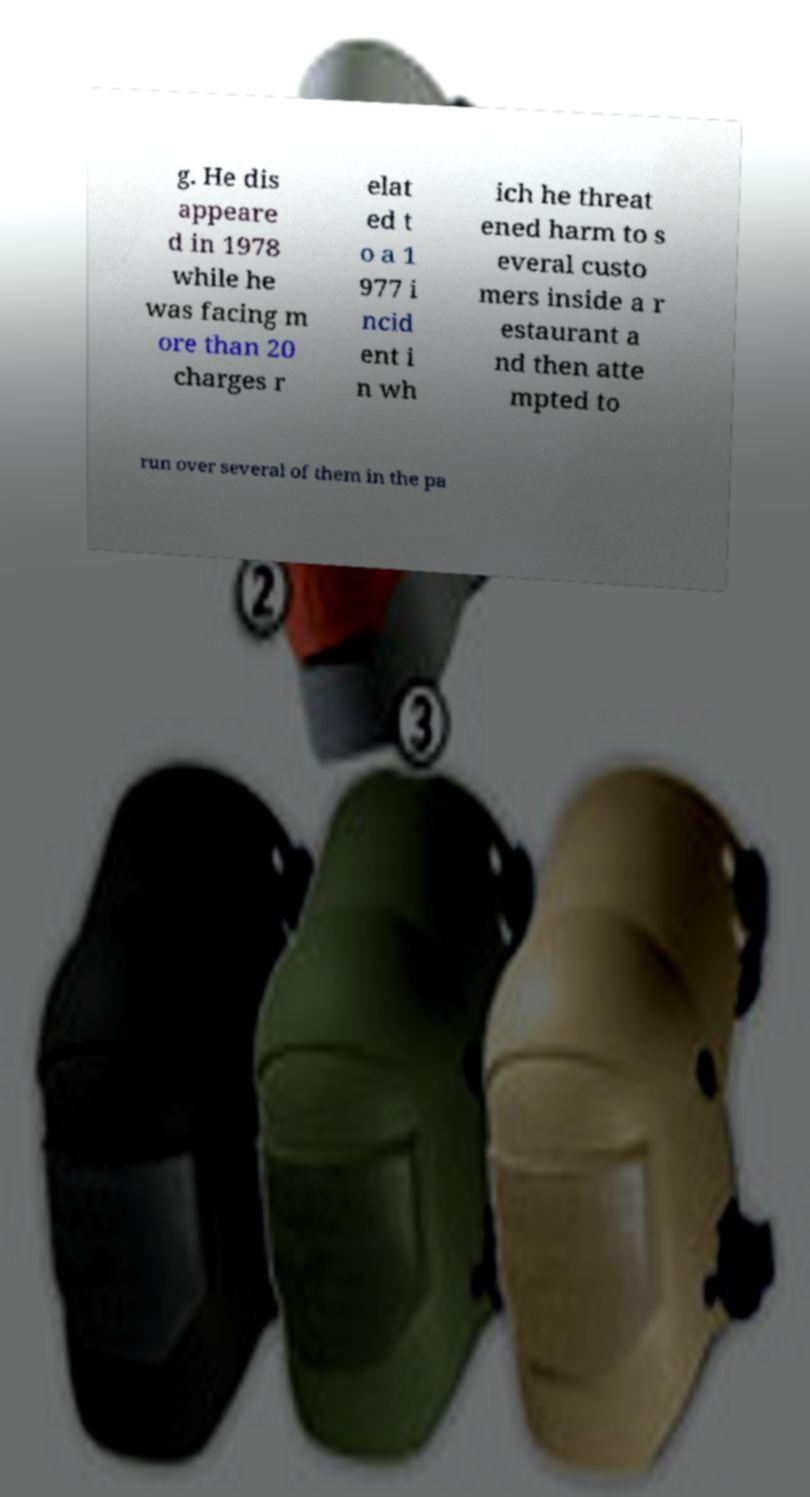What messages or text are displayed in this image? I need them in a readable, typed format. g. He dis appeare d in 1978 while he was facing m ore than 20 charges r elat ed t o a 1 977 i ncid ent i n wh ich he threat ened harm to s everal custo mers inside a r estaurant a nd then atte mpted to run over several of them in the pa 